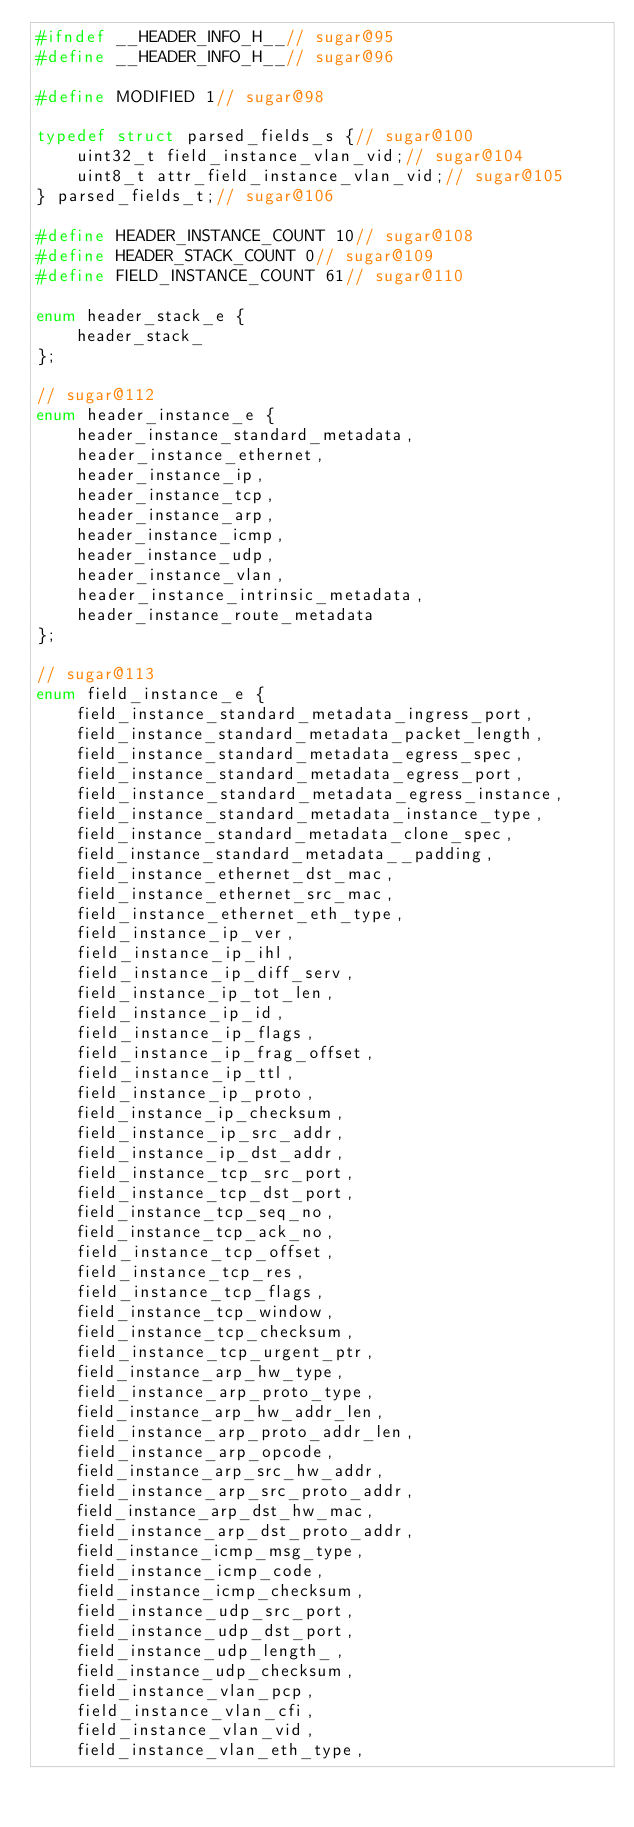Convert code to text. <code><loc_0><loc_0><loc_500><loc_500><_C_>#ifndef __HEADER_INFO_H__// sugar@95
#define __HEADER_INFO_H__// sugar@96

#define MODIFIED 1// sugar@98

typedef struct parsed_fields_s {// sugar@100
    uint32_t field_instance_vlan_vid;// sugar@104
    uint8_t attr_field_instance_vlan_vid;// sugar@105
} parsed_fields_t;// sugar@106

#define HEADER_INSTANCE_COUNT 10// sugar@108
#define HEADER_STACK_COUNT 0// sugar@109
#define FIELD_INSTANCE_COUNT 61// sugar@110

enum header_stack_e {
    header_stack_
};

// sugar@112
enum header_instance_e {
    header_instance_standard_metadata,
    header_instance_ethernet,
    header_instance_ip,
    header_instance_tcp,
    header_instance_arp,
    header_instance_icmp,
    header_instance_udp,
    header_instance_vlan,
    header_instance_intrinsic_metadata,
    header_instance_route_metadata
};

// sugar@113
enum field_instance_e {
    field_instance_standard_metadata_ingress_port,
    field_instance_standard_metadata_packet_length,
    field_instance_standard_metadata_egress_spec,
    field_instance_standard_metadata_egress_port,
    field_instance_standard_metadata_egress_instance,
    field_instance_standard_metadata_instance_type,
    field_instance_standard_metadata_clone_spec,
    field_instance_standard_metadata__padding,
    field_instance_ethernet_dst_mac,
    field_instance_ethernet_src_mac,
    field_instance_ethernet_eth_type,
    field_instance_ip_ver,
    field_instance_ip_ihl,
    field_instance_ip_diff_serv,
    field_instance_ip_tot_len,
    field_instance_ip_id,
    field_instance_ip_flags,
    field_instance_ip_frag_offset,
    field_instance_ip_ttl,
    field_instance_ip_proto,
    field_instance_ip_checksum,
    field_instance_ip_src_addr,
    field_instance_ip_dst_addr,
    field_instance_tcp_src_port,
    field_instance_tcp_dst_port,
    field_instance_tcp_seq_no,
    field_instance_tcp_ack_no,
    field_instance_tcp_offset,
    field_instance_tcp_res,
    field_instance_tcp_flags,
    field_instance_tcp_window,
    field_instance_tcp_checksum,
    field_instance_tcp_urgent_ptr,
    field_instance_arp_hw_type,
    field_instance_arp_proto_type,
    field_instance_arp_hw_addr_len,
    field_instance_arp_proto_addr_len,
    field_instance_arp_opcode,
    field_instance_arp_src_hw_addr,
    field_instance_arp_src_proto_addr,
    field_instance_arp_dst_hw_mac,
    field_instance_arp_dst_proto_addr,
    field_instance_icmp_msg_type,
    field_instance_icmp_code,
    field_instance_icmp_checksum,
    field_instance_udp_src_port,
    field_instance_udp_dst_port,
    field_instance_udp_length_,
    field_instance_udp_checksum,
    field_instance_vlan_pcp,
    field_instance_vlan_cfi,
    field_instance_vlan_vid,
    field_instance_vlan_eth_type,</code> 